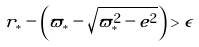Convert formula to latex. <formula><loc_0><loc_0><loc_500><loc_500>r _ { * } - \left ( \varpi _ { * } - \sqrt { \varpi _ { * } ^ { 2 } - e ^ { 2 } } \right ) > \epsilon</formula> 